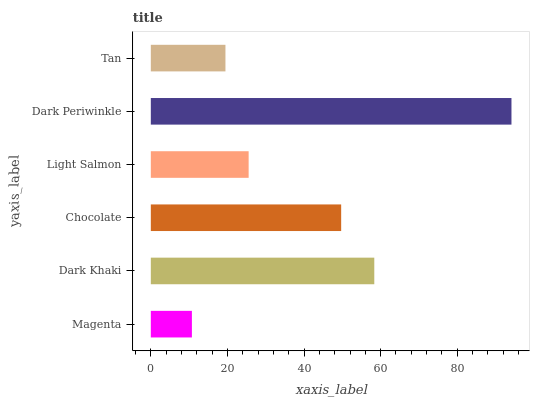Is Magenta the minimum?
Answer yes or no. Yes. Is Dark Periwinkle the maximum?
Answer yes or no. Yes. Is Dark Khaki the minimum?
Answer yes or no. No. Is Dark Khaki the maximum?
Answer yes or no. No. Is Dark Khaki greater than Magenta?
Answer yes or no. Yes. Is Magenta less than Dark Khaki?
Answer yes or no. Yes. Is Magenta greater than Dark Khaki?
Answer yes or no. No. Is Dark Khaki less than Magenta?
Answer yes or no. No. Is Chocolate the high median?
Answer yes or no. Yes. Is Light Salmon the low median?
Answer yes or no. Yes. Is Tan the high median?
Answer yes or no. No. Is Tan the low median?
Answer yes or no. No. 